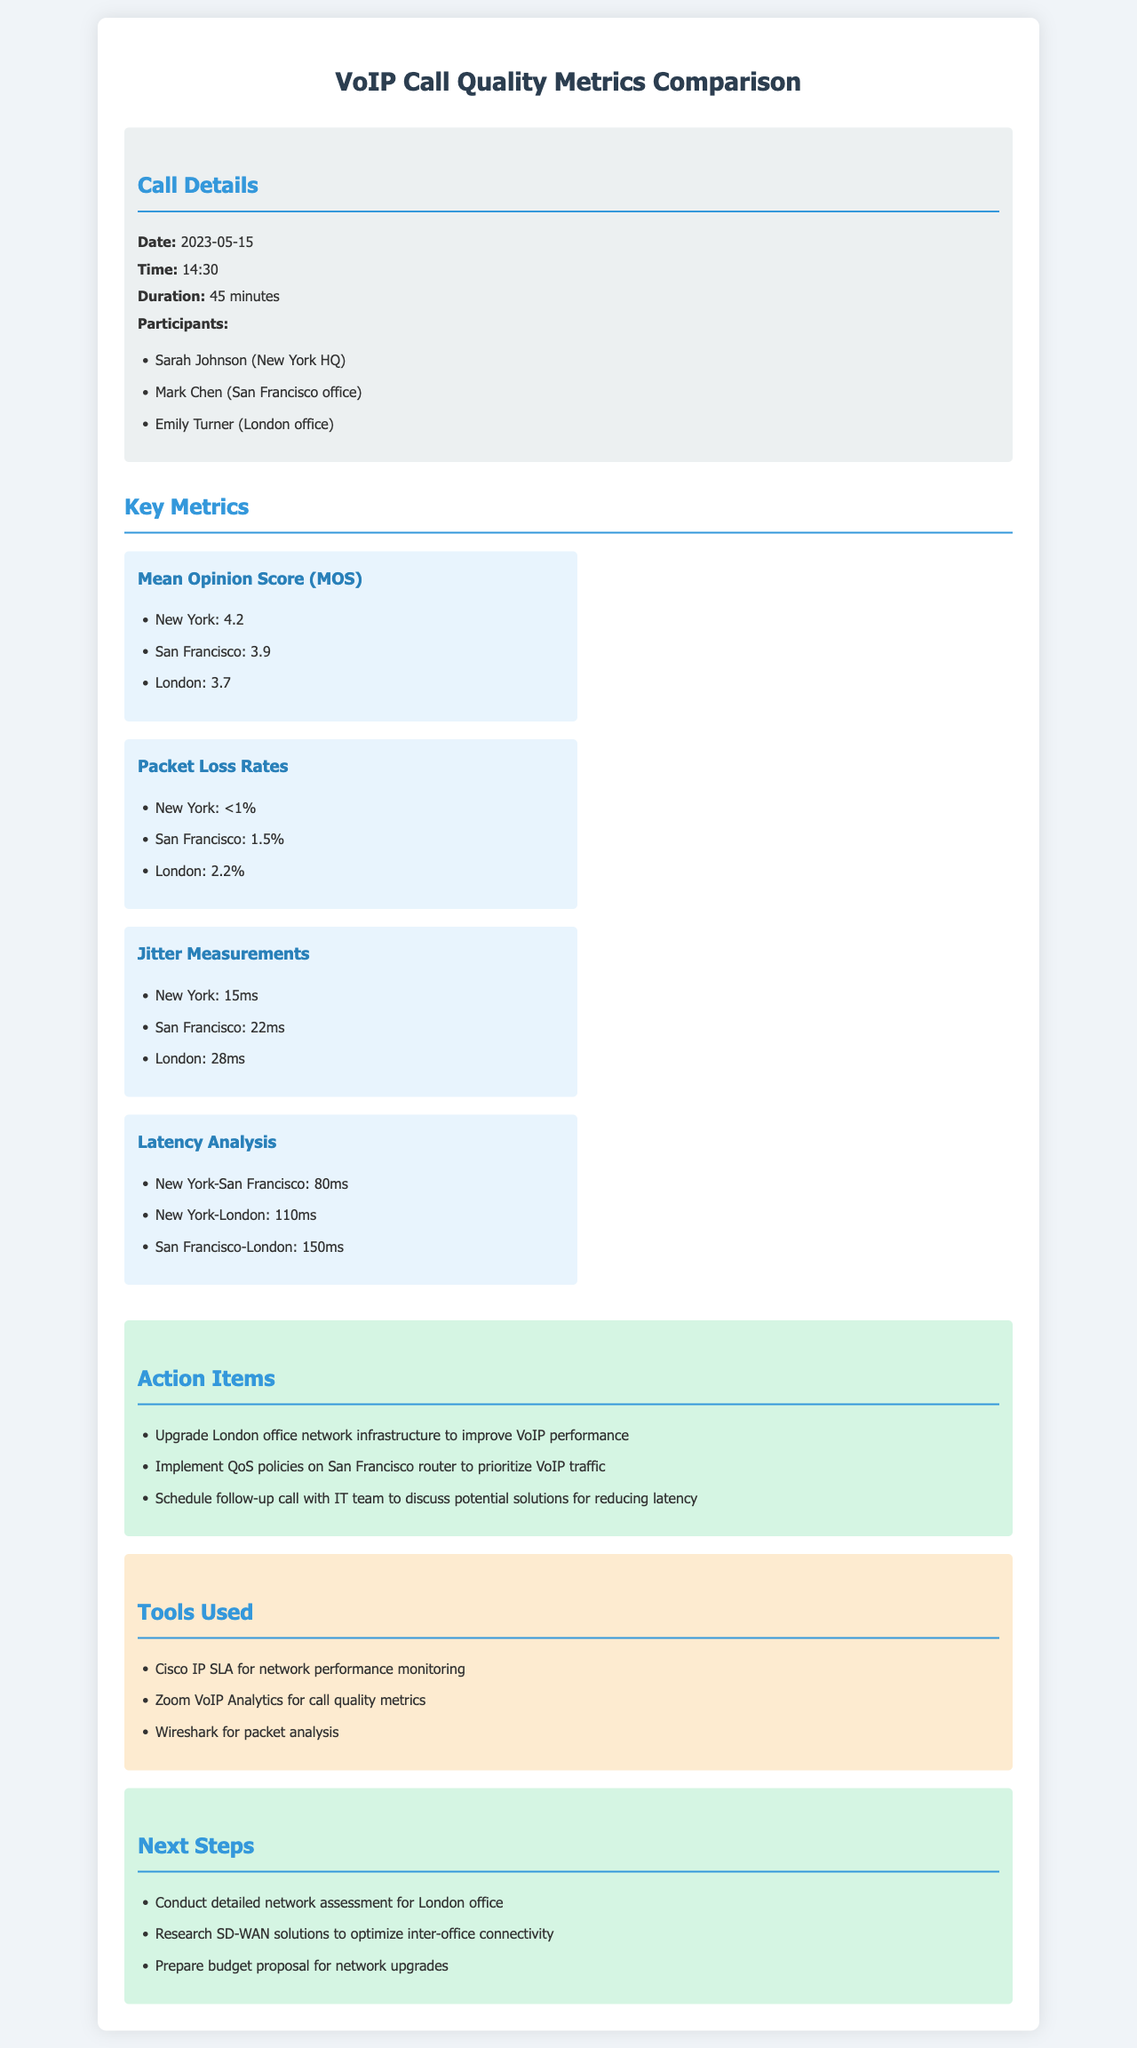What is the date of the call? The date is specified in the call details section of the document.
Answer: 2023-05-15 What is the Mean Opinion Score (MOS) for the New York office? The MOS for the New York office is mentioned under the Key Metrics section.
Answer: 4.2 What is the packet loss rate for the London office? The packet loss rate for the London office is listed in the Key Metrics section.
Answer: 2.2% What does the latency analysis show between New York and London? The latency analysis provides specific latency measurements between different locations.
Answer: 110ms What action is suggested to improve VoIP performance for the London office? Action items include specific recommendations to enhance network performance in the document.
Answer: Upgrade London office network infrastructure What tool is used for network performance monitoring? The tools section lists various software and tools used for analyzing network performance.
Answer: Cisco IP SLA What is the jitter measurement for the San Francisco office? The jitter measurement is listed alongside other key metrics for each office in the document.
Answer: 22ms What is the duration of the call? The duration is specified in the call details section of the document.
Answer: 45 minutes What is one of the next steps mentioned for the London office? The next steps outline plans for further assessment and upgrades in the network section.
Answer: Conduct detailed network assessment for London office 